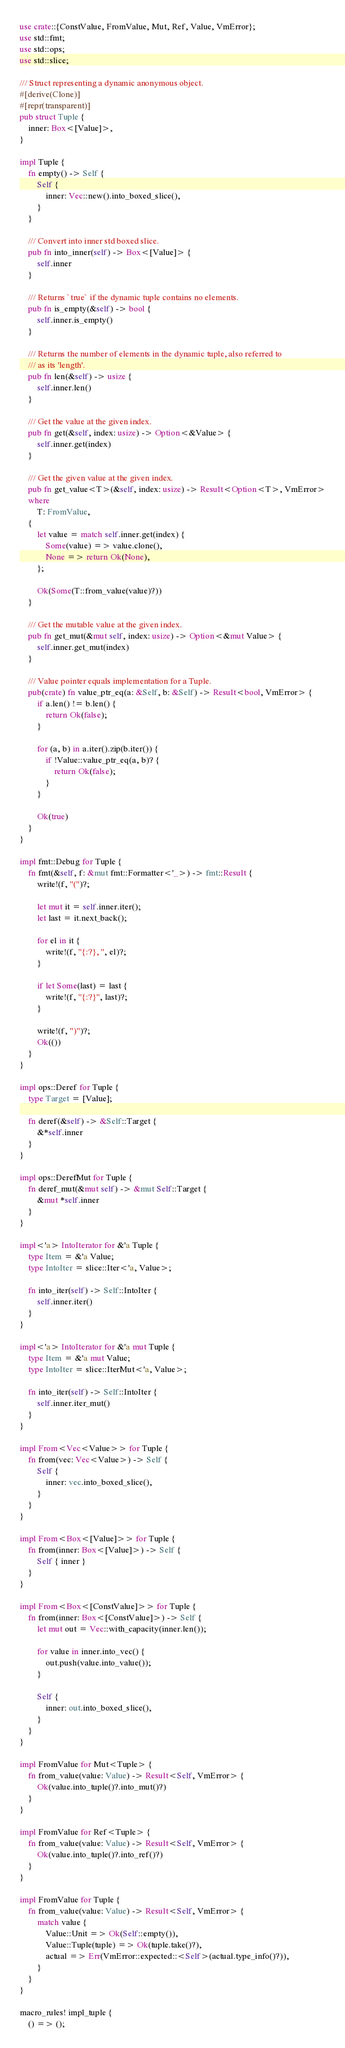<code> <loc_0><loc_0><loc_500><loc_500><_Rust_>use crate::{ConstValue, FromValue, Mut, Ref, Value, VmError};
use std::fmt;
use std::ops;
use std::slice;

/// Struct representing a dynamic anonymous object.
#[derive(Clone)]
#[repr(transparent)]
pub struct Tuple {
    inner: Box<[Value]>,
}

impl Tuple {
    fn empty() -> Self {
        Self {
            inner: Vec::new().into_boxed_slice(),
        }
    }

    /// Convert into inner std boxed slice.
    pub fn into_inner(self) -> Box<[Value]> {
        self.inner
    }

    /// Returns `true` if the dynamic tuple contains no elements.
    pub fn is_empty(&self) -> bool {
        self.inner.is_empty()
    }

    /// Returns the number of elements in the dynamic tuple, also referred to
    /// as its 'length'.
    pub fn len(&self) -> usize {
        self.inner.len()
    }

    /// Get the value at the given index.
    pub fn get(&self, index: usize) -> Option<&Value> {
        self.inner.get(index)
    }

    /// Get the given value at the given index.
    pub fn get_value<T>(&self, index: usize) -> Result<Option<T>, VmError>
    where
        T: FromValue,
    {
        let value = match self.inner.get(index) {
            Some(value) => value.clone(),
            None => return Ok(None),
        };

        Ok(Some(T::from_value(value)?))
    }

    /// Get the mutable value at the given index.
    pub fn get_mut(&mut self, index: usize) -> Option<&mut Value> {
        self.inner.get_mut(index)
    }

    /// Value pointer equals implementation for a Tuple.
    pub(crate) fn value_ptr_eq(a: &Self, b: &Self) -> Result<bool, VmError> {
        if a.len() != b.len() {
            return Ok(false);
        }

        for (a, b) in a.iter().zip(b.iter()) {
            if !Value::value_ptr_eq(a, b)? {
                return Ok(false);
            }
        }

        Ok(true)
    }
}

impl fmt::Debug for Tuple {
    fn fmt(&self, f: &mut fmt::Formatter<'_>) -> fmt::Result {
        write!(f, "(")?;

        let mut it = self.inner.iter();
        let last = it.next_back();

        for el in it {
            write!(f, "{:?}, ", el)?;
        }

        if let Some(last) = last {
            write!(f, "{:?}", last)?;
        }

        write!(f, ")")?;
        Ok(())
    }
}

impl ops::Deref for Tuple {
    type Target = [Value];

    fn deref(&self) -> &Self::Target {
        &*self.inner
    }
}

impl ops::DerefMut for Tuple {
    fn deref_mut(&mut self) -> &mut Self::Target {
        &mut *self.inner
    }
}

impl<'a> IntoIterator for &'a Tuple {
    type Item = &'a Value;
    type IntoIter = slice::Iter<'a, Value>;

    fn into_iter(self) -> Self::IntoIter {
        self.inner.iter()
    }
}

impl<'a> IntoIterator for &'a mut Tuple {
    type Item = &'a mut Value;
    type IntoIter = slice::IterMut<'a, Value>;

    fn into_iter(self) -> Self::IntoIter {
        self.inner.iter_mut()
    }
}

impl From<Vec<Value>> for Tuple {
    fn from(vec: Vec<Value>) -> Self {
        Self {
            inner: vec.into_boxed_slice(),
        }
    }
}

impl From<Box<[Value]>> for Tuple {
    fn from(inner: Box<[Value]>) -> Self {
        Self { inner }
    }
}

impl From<Box<[ConstValue]>> for Tuple {
    fn from(inner: Box<[ConstValue]>) -> Self {
        let mut out = Vec::with_capacity(inner.len());

        for value in inner.into_vec() {
            out.push(value.into_value());
        }

        Self {
            inner: out.into_boxed_slice(),
        }
    }
}

impl FromValue for Mut<Tuple> {
    fn from_value(value: Value) -> Result<Self, VmError> {
        Ok(value.into_tuple()?.into_mut()?)
    }
}

impl FromValue for Ref<Tuple> {
    fn from_value(value: Value) -> Result<Self, VmError> {
        Ok(value.into_tuple()?.into_ref()?)
    }
}

impl FromValue for Tuple {
    fn from_value(value: Value) -> Result<Self, VmError> {
        match value {
            Value::Unit => Ok(Self::empty()),
            Value::Tuple(tuple) => Ok(tuple.take()?),
            actual => Err(VmError::expected::<Self>(actual.type_info()?)),
        }
    }
}

macro_rules! impl_tuple {
    () => ();
</code> 